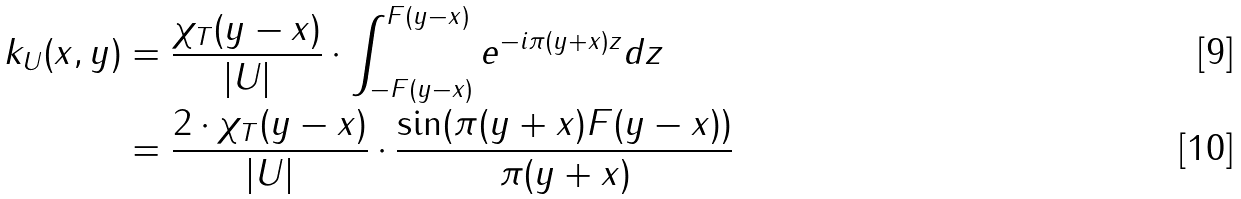<formula> <loc_0><loc_0><loc_500><loc_500>k _ { U } ( x , y ) & = \frac { \chi _ { T } ( y - x ) } { | U | } \cdot \int _ { - F ( y - x ) } ^ { F ( y - x ) } e ^ { - i \pi ( y + x ) z } d z \\ & = \frac { 2 \cdot \chi _ { T } ( y - x ) } { | U | } \cdot \frac { \sin ( \pi ( y + x ) F ( y - x ) ) } { \pi ( y + x ) }</formula> 